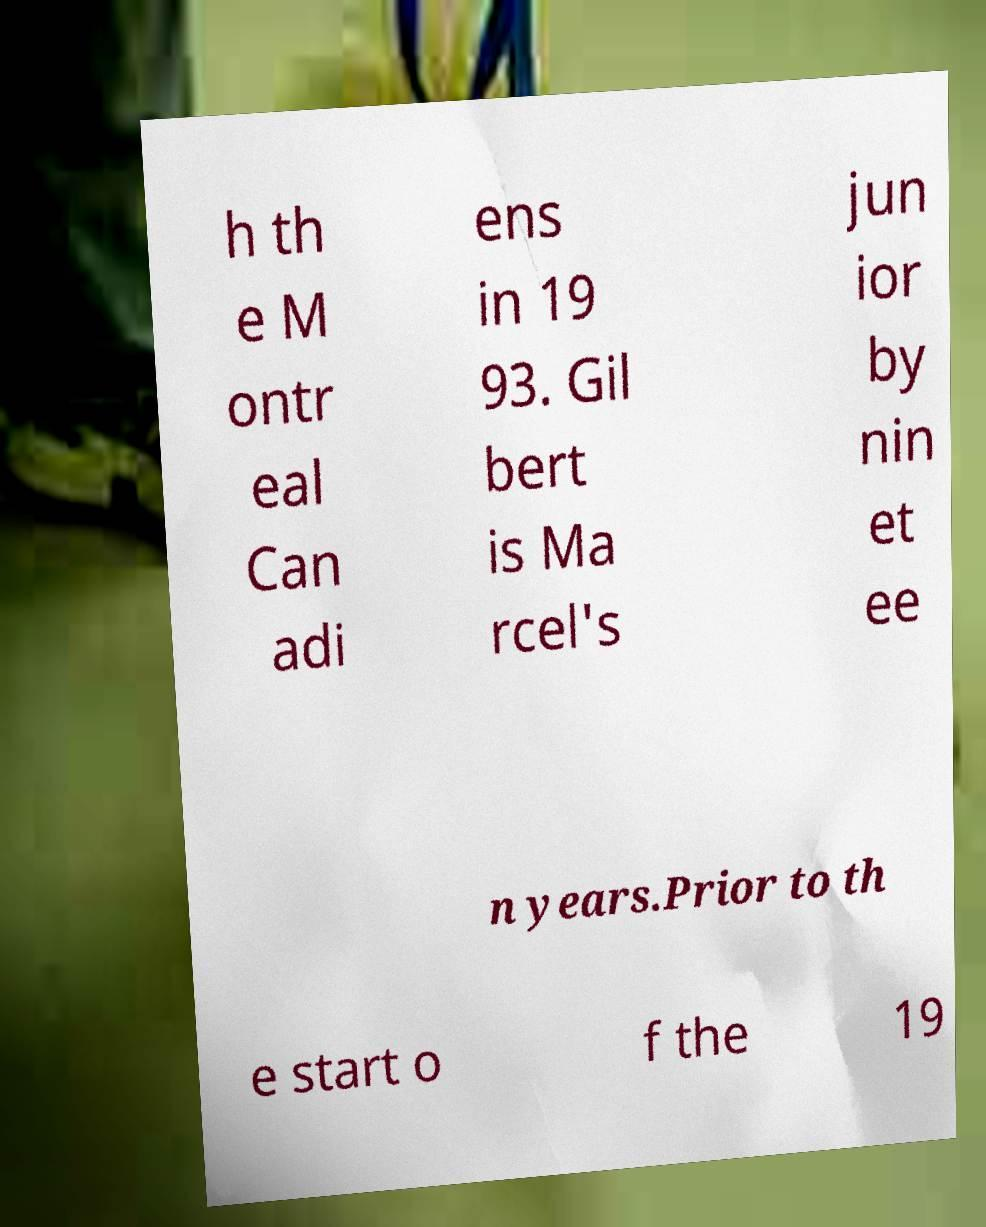Could you extract and type out the text from this image? h th e M ontr eal Can adi ens in 19 93. Gil bert is Ma rcel's jun ior by nin et ee n years.Prior to th e start o f the 19 